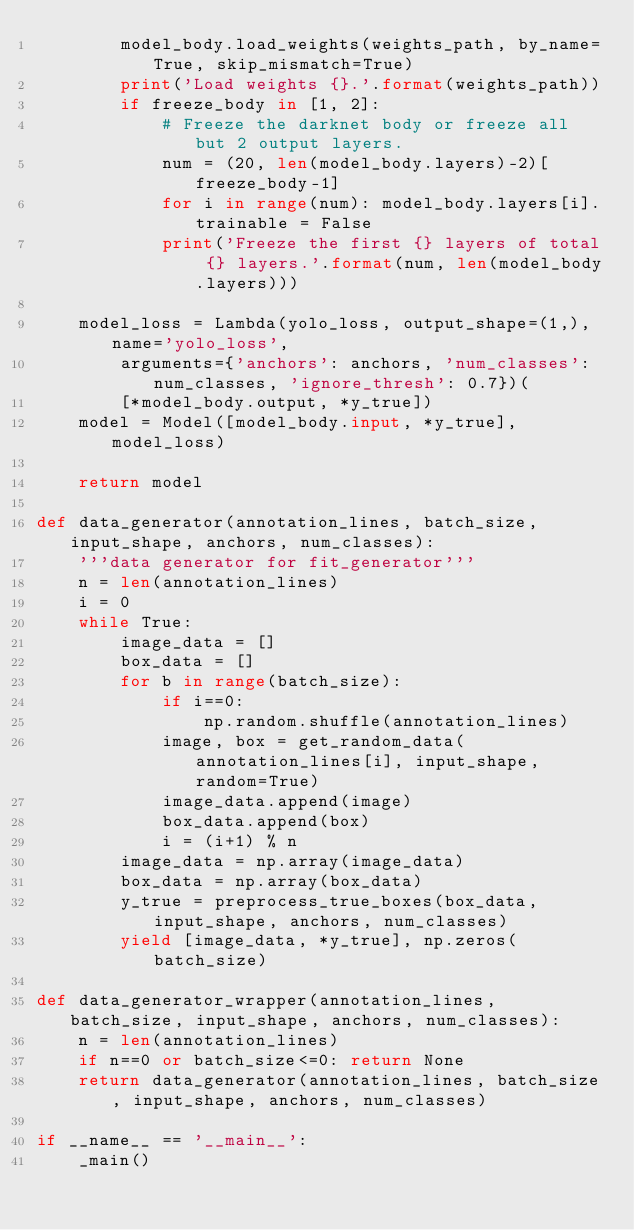Convert code to text. <code><loc_0><loc_0><loc_500><loc_500><_Python_>        model_body.load_weights(weights_path, by_name=True, skip_mismatch=True)
        print('Load weights {}.'.format(weights_path))
        if freeze_body in [1, 2]:
            # Freeze the darknet body or freeze all but 2 output layers.
            num = (20, len(model_body.layers)-2)[freeze_body-1]
            for i in range(num): model_body.layers[i].trainable = False
            print('Freeze the first {} layers of total {} layers.'.format(num, len(model_body.layers)))

    model_loss = Lambda(yolo_loss, output_shape=(1,), name='yolo_loss',
        arguments={'anchors': anchors, 'num_classes': num_classes, 'ignore_thresh': 0.7})(
        [*model_body.output, *y_true])
    model = Model([model_body.input, *y_true], model_loss)

    return model

def data_generator(annotation_lines, batch_size, input_shape, anchors, num_classes):
    '''data generator for fit_generator'''
    n = len(annotation_lines)
    i = 0
    while True:
        image_data = []
        box_data = []
        for b in range(batch_size):
            if i==0:
                np.random.shuffle(annotation_lines)
            image, box = get_random_data(annotation_lines[i], input_shape, random=True)
            image_data.append(image)
            box_data.append(box)
            i = (i+1) % n
        image_data = np.array(image_data)
        box_data = np.array(box_data)
        y_true = preprocess_true_boxes(box_data, input_shape, anchors, num_classes)
        yield [image_data, *y_true], np.zeros(batch_size)

def data_generator_wrapper(annotation_lines, batch_size, input_shape, anchors, num_classes):
    n = len(annotation_lines)
    if n==0 or batch_size<=0: return None
    return data_generator(annotation_lines, batch_size, input_shape, anchors, num_classes)

if __name__ == '__main__':
    _main()
</code> 